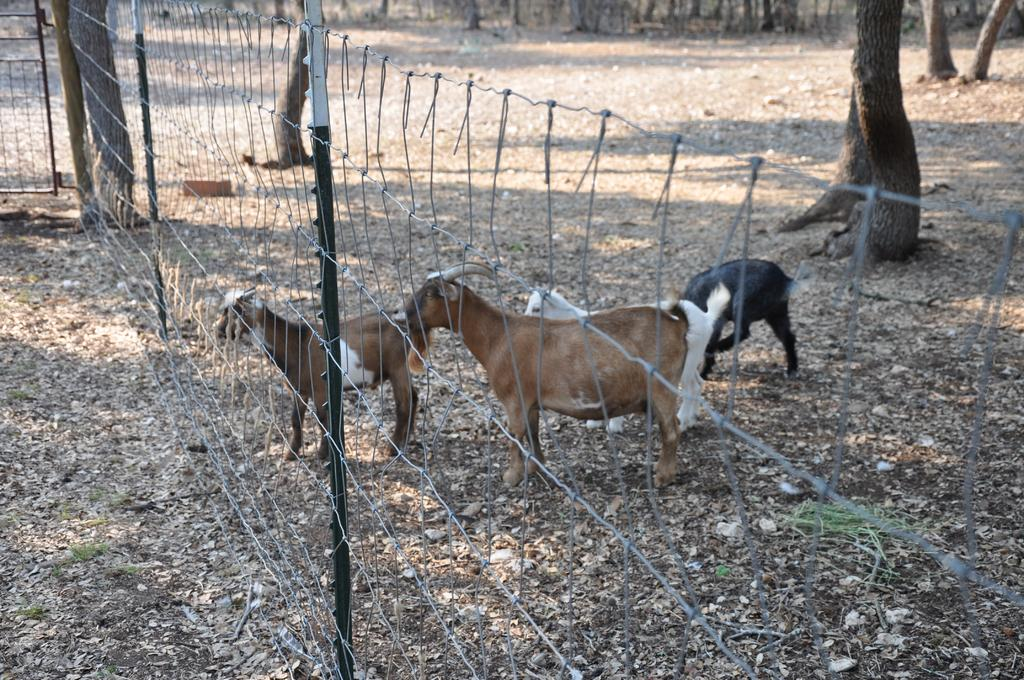What animals are in the image? There are goats in the image. Where are the goats located in relation to the fence? The goats are in front of a fence. What type of vegetation can be seen in the image? There are trees in the image. What material are the rods made of in the image? Metal rods are present in the image. Who is the servant attending to in the image? There is no servant present in the image. What type of industry is depicted in the image? There is no industry depicted in the image; it features goats in front of a fence. 